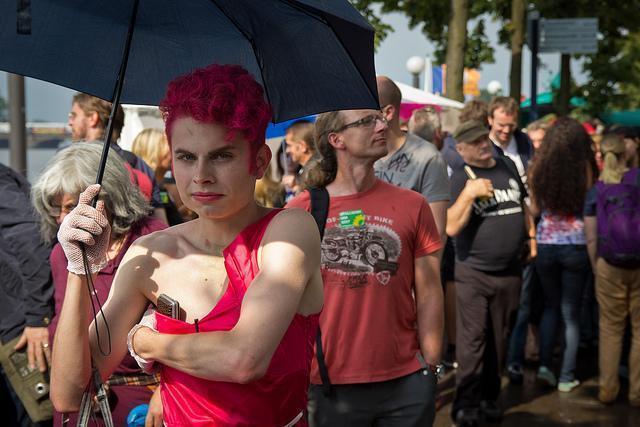Why does the man holding the umbrella have very red lips?
Make your selection from the four choices given to correctly answer the question.
Options: He's sick, chapstick, genetics, lipstick. Lipstick. 